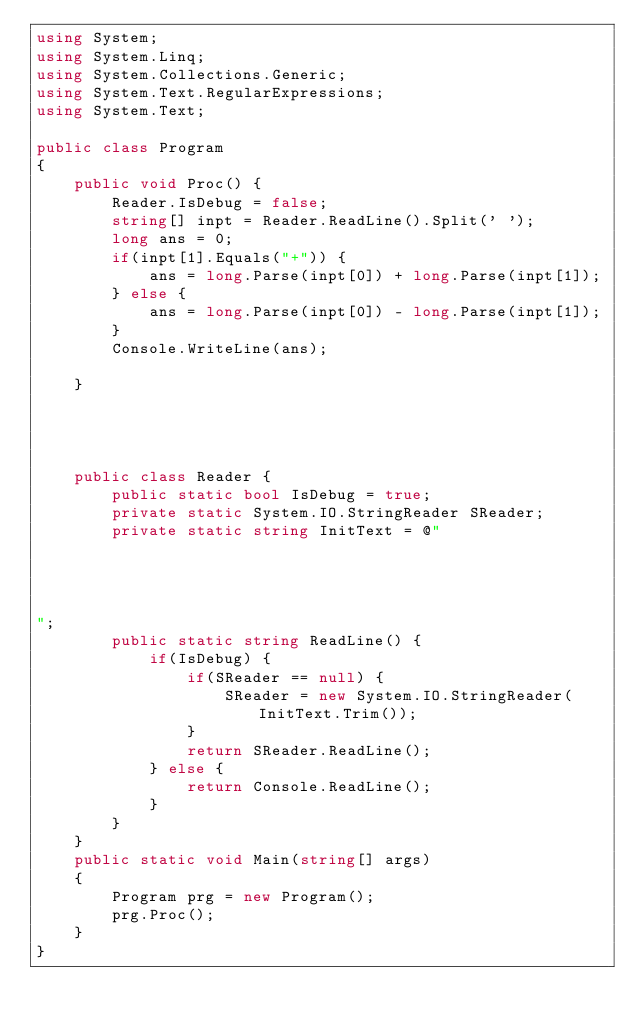Convert code to text. <code><loc_0><loc_0><loc_500><loc_500><_C#_>using System;
using System.Linq;
using System.Collections.Generic;
using System.Text.RegularExpressions;
using System.Text;
 
public class Program
{
    public void Proc() {
        Reader.IsDebug = false;
        string[] inpt = Reader.ReadLine().Split(' ');
        long ans = 0;
        if(inpt[1].Equals("+")) {
            ans = long.Parse(inpt[0]) + long.Parse(inpt[1]);
        } else {
            ans = long.Parse(inpt[0]) - long.Parse(inpt[1]);
        }
        Console.WriteLine(ans);

    }




    public class Reader {
        public static bool IsDebug = true;
        private static System.IO.StringReader SReader;
        private static string InitText = @"




";
        public static string ReadLine() {
            if(IsDebug) {
                if(SReader == null) {
                    SReader = new System.IO.StringReader(InitText.Trim());
                }
                return SReader.ReadLine();
            } else {
                return Console.ReadLine();
            }
        }
    }
    public static void Main(string[] args)
    {
        Program prg = new Program();
        prg.Proc();
    }
}
</code> 